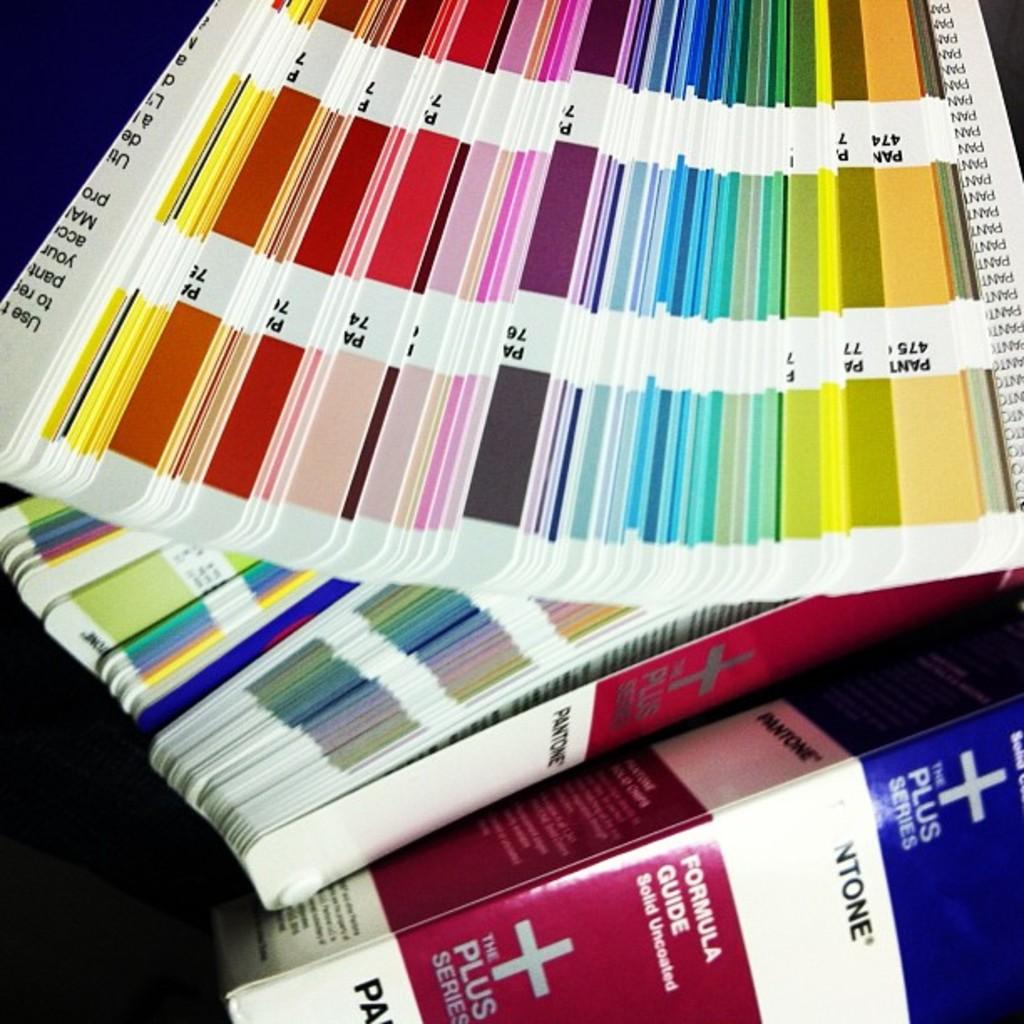What series is the formula guide?
Provide a succinct answer. Plus. What is the register trademark name?
Your response must be concise. Pantone. 